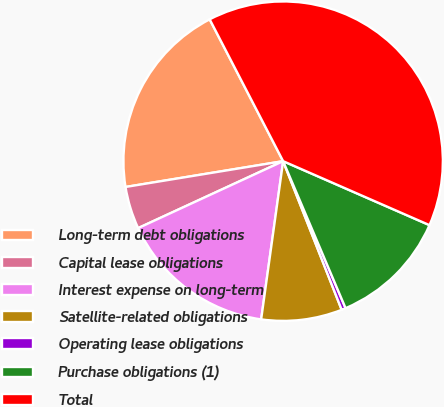Convert chart to OTSL. <chart><loc_0><loc_0><loc_500><loc_500><pie_chart><fcel>Long-term debt obligations<fcel>Capital lease obligations<fcel>Interest expense on long-term<fcel>Satellite-related obligations<fcel>Operating lease obligations<fcel>Purchase obligations (1)<fcel>Total<nl><fcel>19.98%<fcel>4.3%<fcel>15.92%<fcel>8.17%<fcel>0.42%<fcel>12.05%<fcel>39.17%<nl></chart> 